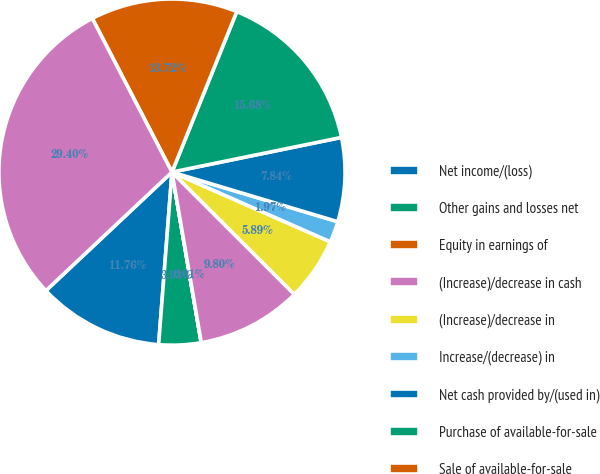Convert chart. <chart><loc_0><loc_0><loc_500><loc_500><pie_chart><fcel>Net income/(loss)<fcel>Other gains and losses net<fcel>Equity in earnings of<fcel>(Increase)/decrease in cash<fcel>(Increase)/decrease in<fcel>Increase/(decrease) in<fcel>Net cash provided by/(used in)<fcel>Purchase of available-for-sale<fcel>Sale of available-for-sale<fcel>Purchase of investments by CIP<nl><fcel>11.76%<fcel>3.93%<fcel>0.01%<fcel>9.8%<fcel>5.89%<fcel>1.97%<fcel>7.84%<fcel>15.68%<fcel>13.72%<fcel>29.4%<nl></chart> 